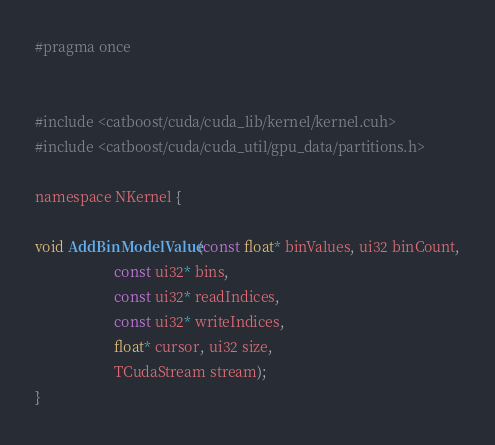<code> <loc_0><loc_0><loc_500><loc_500><_Cuda_>#pragma once


#include <catboost/cuda/cuda_lib/kernel/kernel.cuh>
#include <catboost/cuda/cuda_util/gpu_data/partitions.h>

namespace NKernel {

void AddBinModelValue(const float* binValues, ui32 binCount,
                      const ui32* bins,
                      const ui32* readIndices,
                      const ui32* writeIndices,
                      float* cursor, ui32 size,
                      TCudaStream stream);
}
</code> 